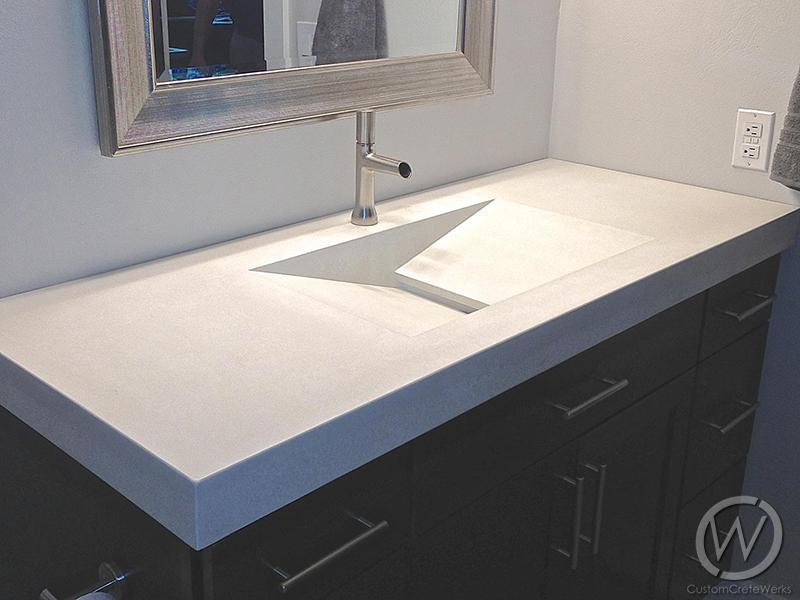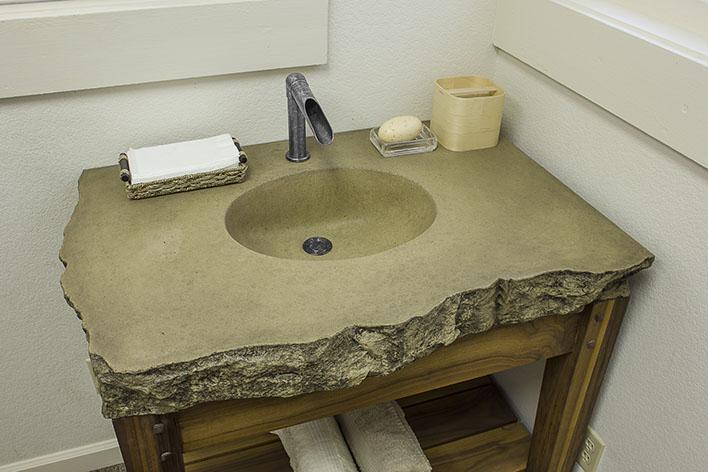The first image is the image on the left, the second image is the image on the right. Assess this claim about the two images: "Each image shows a grey/silver vanity with only one sink.". Correct or not? Answer yes or no. Yes. The first image is the image on the left, the second image is the image on the right. Given the left and right images, does the statement "There are three faucets." hold true? Answer yes or no. No. 